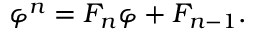<formula> <loc_0><loc_0><loc_500><loc_500>\varphi ^ { n } = F _ { n } \varphi + F _ { n - 1 } .</formula> 